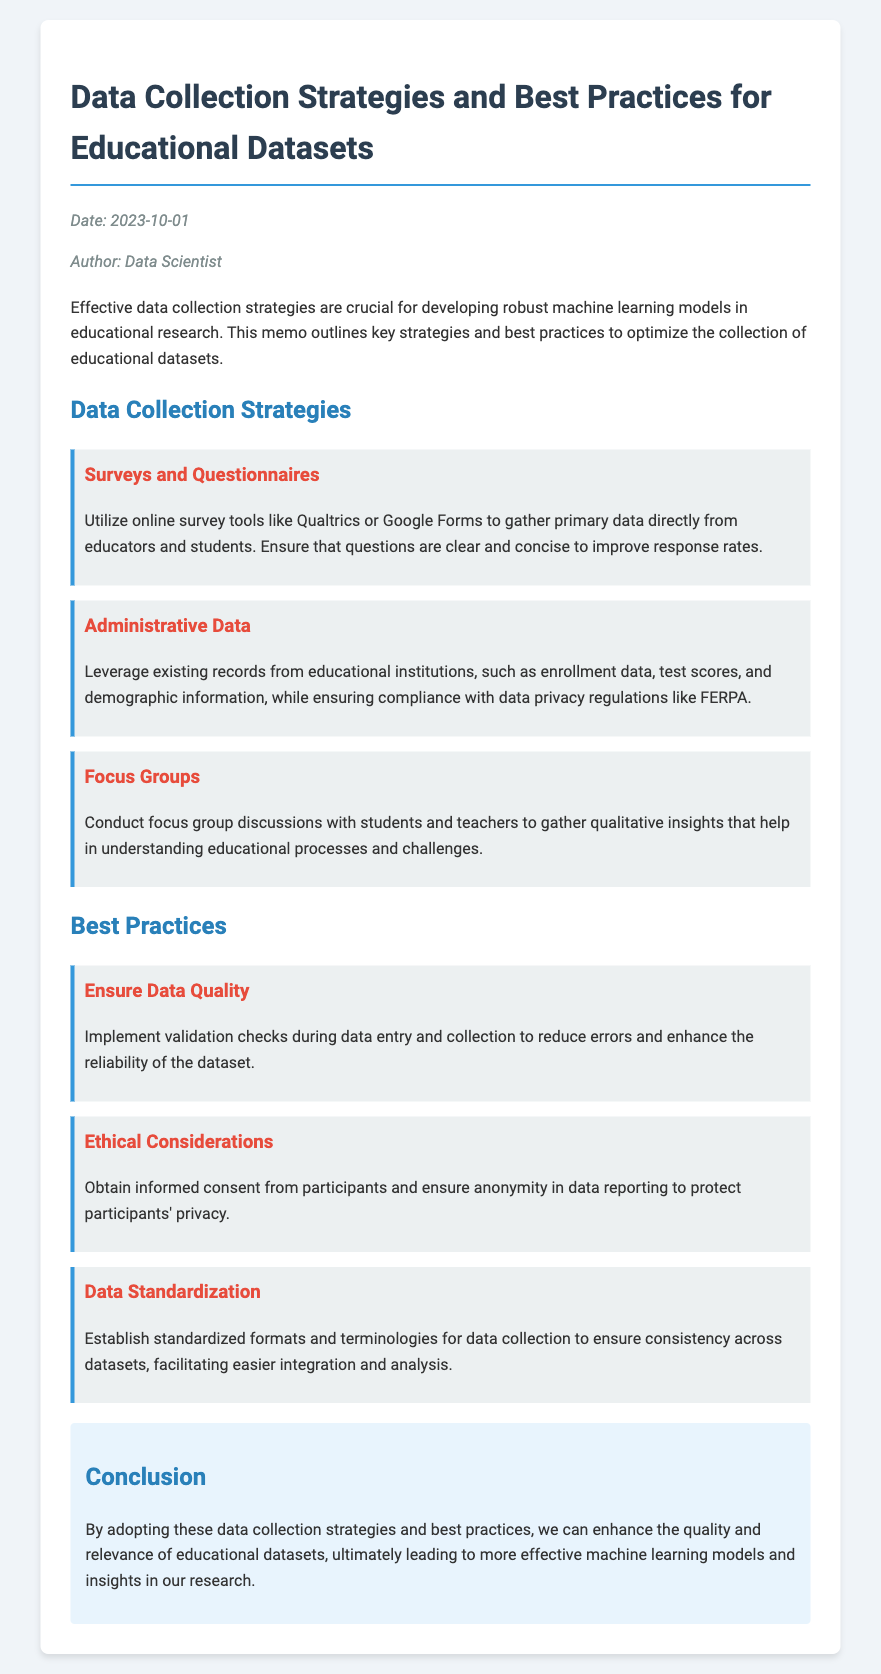What is the date of the memo? The date listed in the memo is crucial for understanding its relevance and context.
Answer: 2023-10-01 Who is the author of the memo? The author of the memo provides credibility to the information presented.
Answer: Data Scientist What is a recommended tool for surveys? The mention of specific tools helps in choosing the appropriate method for data collection.
Answer: Qualtrics What should be ensured regarding participant privacy? Understanding the importance of privacy safeguards is essential in educational research.
Answer: Anonymity What is a key strategy for data collection? Identifying main strategies provides clarity on effective methodologies for data collection.
Answer: Focus Groups What is a best practice for data quality? Best practices are essential for ensuring the reliability of datasets.
Answer: Validation checks What is emphasized regarding data standardization? Knowledge of standardization is important for consistent data across studies.
Answer: Standardized formats How many strategies for data collection are outlined? Knowing the number of strategies helps in grasping the comprehensiveness of the memo.
Answer: Three What ethical consideration is mentioned in the memo? Ethical considerations are pivotal in the context of educational research involving human subjects.
Answer: Informed consent 